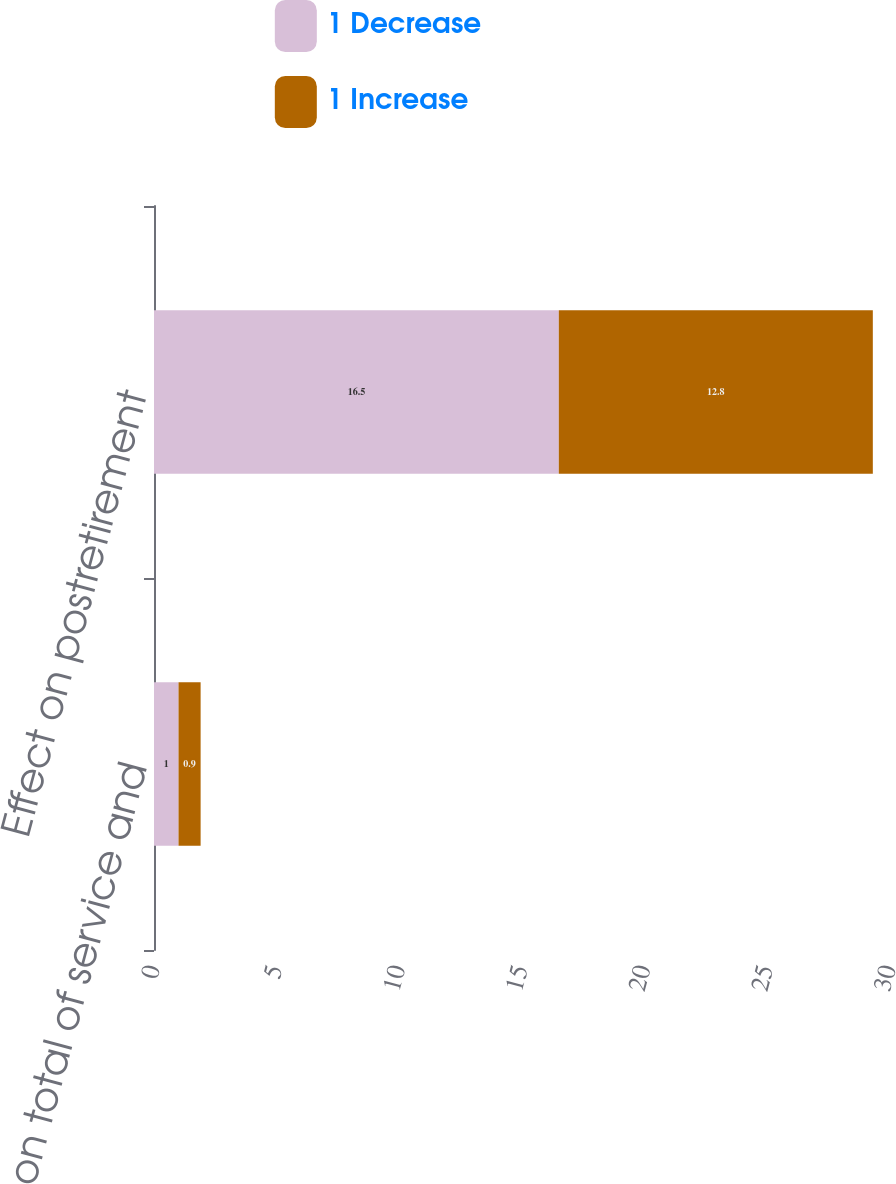Convert chart. <chart><loc_0><loc_0><loc_500><loc_500><stacked_bar_chart><ecel><fcel>Effect on total of service and<fcel>Effect on postretirement<nl><fcel>1 Decrease<fcel>1<fcel>16.5<nl><fcel>1 Increase<fcel>0.9<fcel>12.8<nl></chart> 